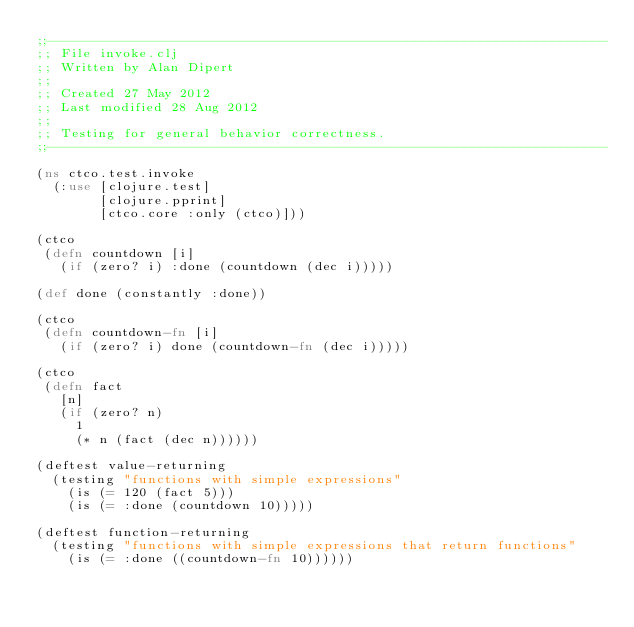Convert code to text. <code><loc_0><loc_0><loc_500><loc_500><_Clojure_>;;----------------------------------------------------------------------
;; File invoke.clj
;; Written by Alan Dipert
;;
;; Created 27 May 2012
;; Last modified 28 Aug 2012
;;
;; Testing for general behavior correctness.
;;----------------------------------------------------------------------

(ns ctco.test.invoke
  (:use [clojure.test]
        [clojure.pprint]
        [ctco.core :only (ctco)]))

(ctco
 (defn countdown [i]
   (if (zero? i) :done (countdown (dec i)))))

(def done (constantly :done))

(ctco
 (defn countdown-fn [i]
   (if (zero? i) done (countdown-fn (dec i)))))

(ctco
 (defn fact
   [n]
   (if (zero? n)
     1
     (* n (fact (dec n))))))

(deftest value-returning
  (testing "functions with simple expressions"
    (is (= 120 (fact 5)))
    (is (= :done (countdown 10)))))

(deftest function-returning
  (testing "functions with simple expressions that return functions"
    (is (= :done ((countdown-fn 10))))))
</code> 